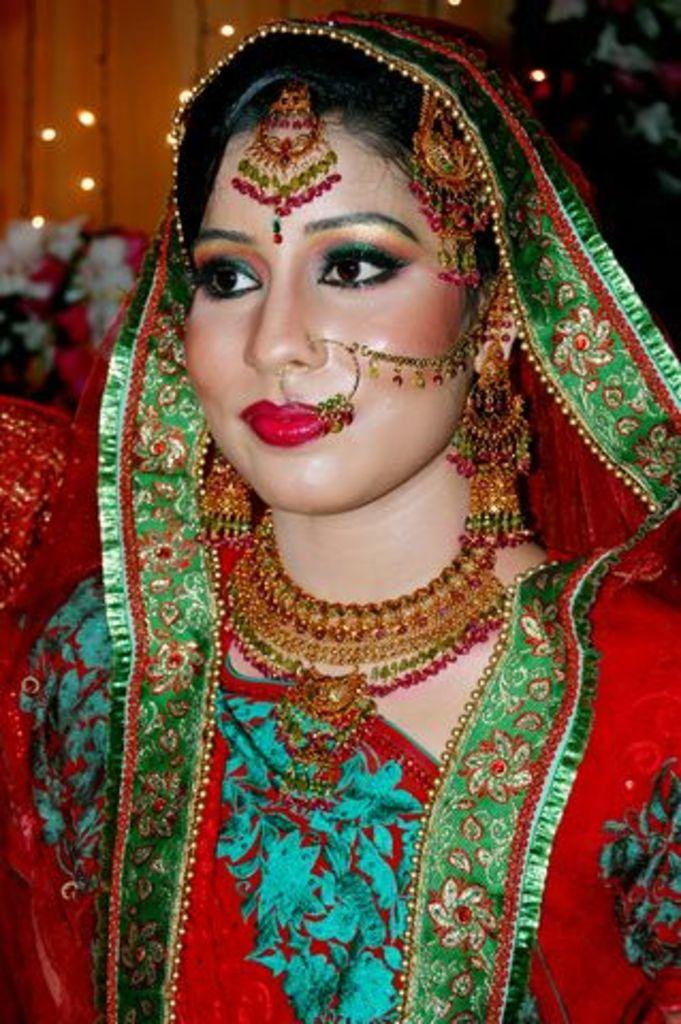Who is present in the image? There is a woman in the image. What is the woman wearing on her head? The woman is wearing a cloth on her head. What can be seen on the left side of the image? There are flowers on the left side of the image. What is visible in the background of the image? There is a wall in the background of the image, and there are lights on the wall. Can you tell me how many brothers are present in the image? There are no brothers present in the image; it features a woman wearing a cloth on her head. What type of rainstorm can be seen in the image? There is no rainstorm present in the image; it features a woman, flowers, and a wall with lights. 